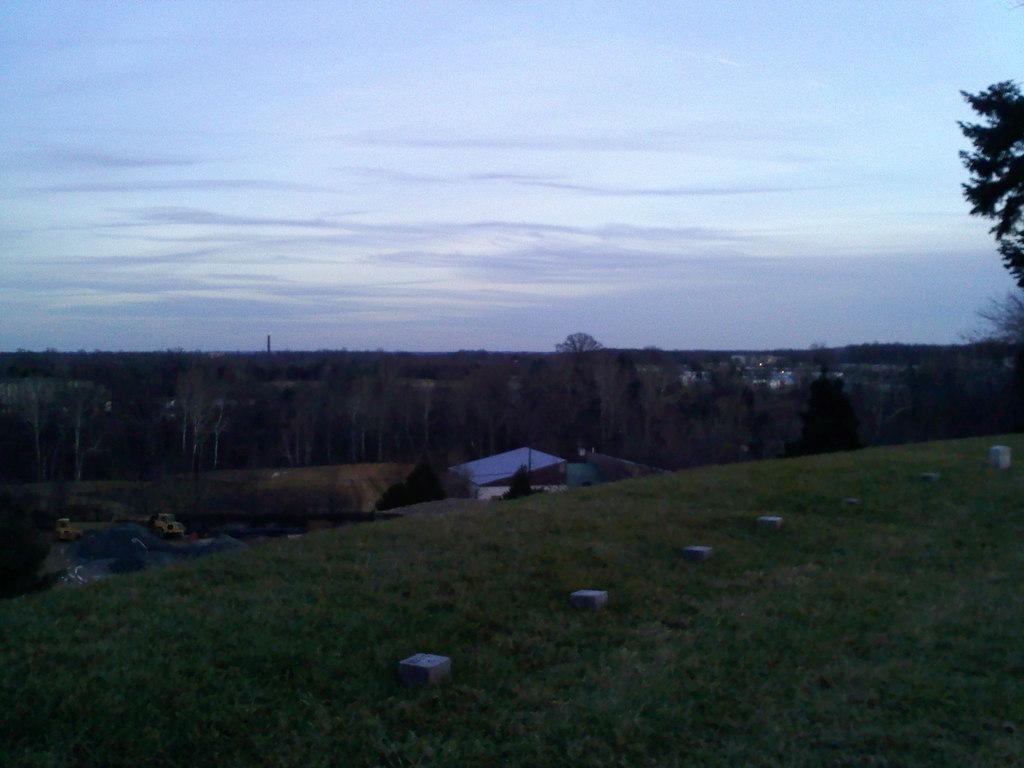What type of vegetation can be seen in the image? There is grass, plants, and trees in the image. What else can be seen on the ground in the image? There are vehicles on the road in the image. What type of structures are visible in the image? There are houses in the image. What else can be seen in the image besides the vegetation and structures? There are poles in the image. What is visible in the sky in the image? The sky is visible in the image. Can you describe the time of day based on the image? The image may have been taken in the evening, as the sky appears to be darker. How many cows are grazing in the grass in the image? There are no cows present in the image; it features grass, plants, trees, vehicles, houses, poles, and a sky. What type of weapon is being used by the person in the image? There is no person or weapon present in the image. 